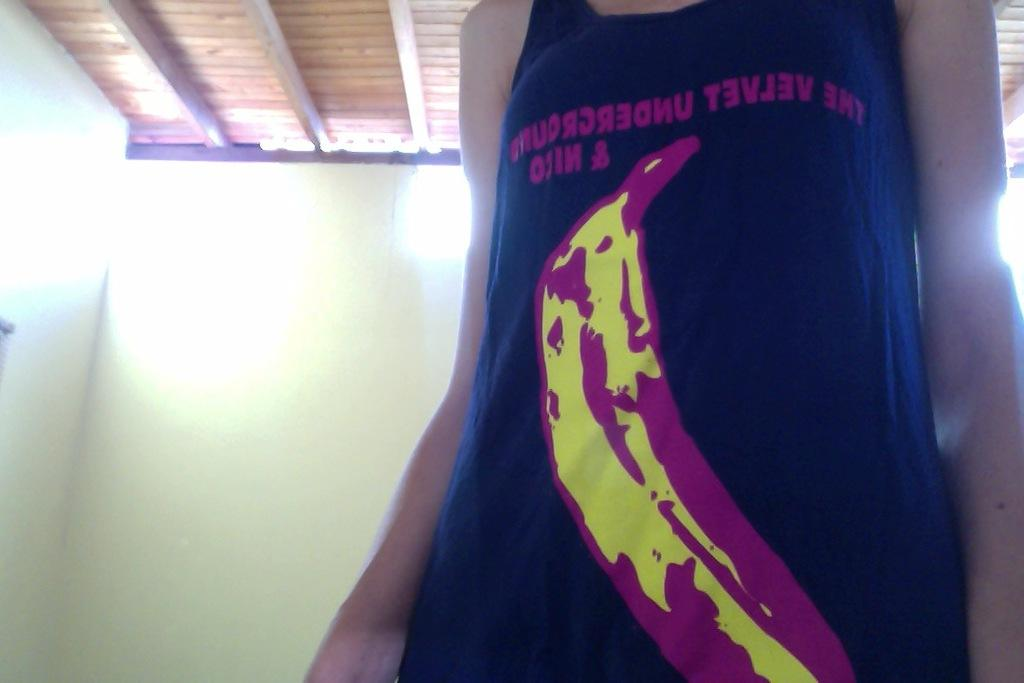<image>
Render a clear and concise summary of the photo. a mirrored image of a tanktop reading 'the velvet underground' 